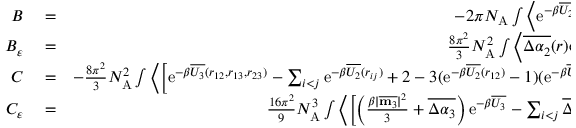<formula> <loc_0><loc_0><loc_500><loc_500>\begin{array} { r l r } { B } & = } & { - 2 \pi N _ { A } \int \left \langle e ^ { - \beta \overline { { U _ { 2 } } } ( r _ { 1 2 } ) } - 1 \right \rangle r _ { 1 2 } ^ { 2 } d r _ { 1 2 } } \\ { B _ { \varepsilon } } & = } & { \frac { 8 \pi ^ { 2 } } { 3 } N _ { A } ^ { 2 } \int \left \langle \overline { { \Delta \alpha _ { 2 } } } ( r ) e ^ { - \beta \overline { { U _ { 2 } } } ( r _ { 1 2 } ) } \right \rangle r _ { 1 2 } ^ { 2 } d r _ { 1 2 } } \\ { C } & = } & { - \frac { 8 \pi ^ { 2 } } { 3 } N _ { A } ^ { 2 } \int \left \langle \left [ e ^ { - \beta \overline { { U _ { 3 } } } ( r _ { 1 2 } , r _ { 1 3 } , r _ { 2 3 } ) } - \sum _ { i < j } e ^ { - \beta \overline { { U _ { 2 } } } ( r _ { i j } ) } + 2 - 3 ( e ^ { - \beta \overline { { U _ { 2 } } } ( r _ { 1 2 } ) } - 1 ) ( e ^ { - \beta \overline { { U _ { 2 } } } ( r _ { 1 3 } ) } - 1 ) \right ] \right \rangle d \Omega _ { 3 } } \\ { C _ { \varepsilon } } & = } & { \frac { 1 6 \pi ^ { 2 } } { 9 } N _ { A } ^ { 3 } \int \left \langle \left [ \left ( \frac { \beta | \overline { { m _ { 3 } } } | ^ { 2 } } { 3 } + \overline { { \Delta \alpha _ { 3 } } } \right ) e ^ { - \beta \overline { { U _ { 3 } } } } - \sum _ { i < j } \overline { { \Delta \alpha _ { 2 } } } ( r _ { i j } ) e ^ { - \beta \overline { { U _ { 2 } } } ( r _ { i j } ) } - } \end{array}</formula> 